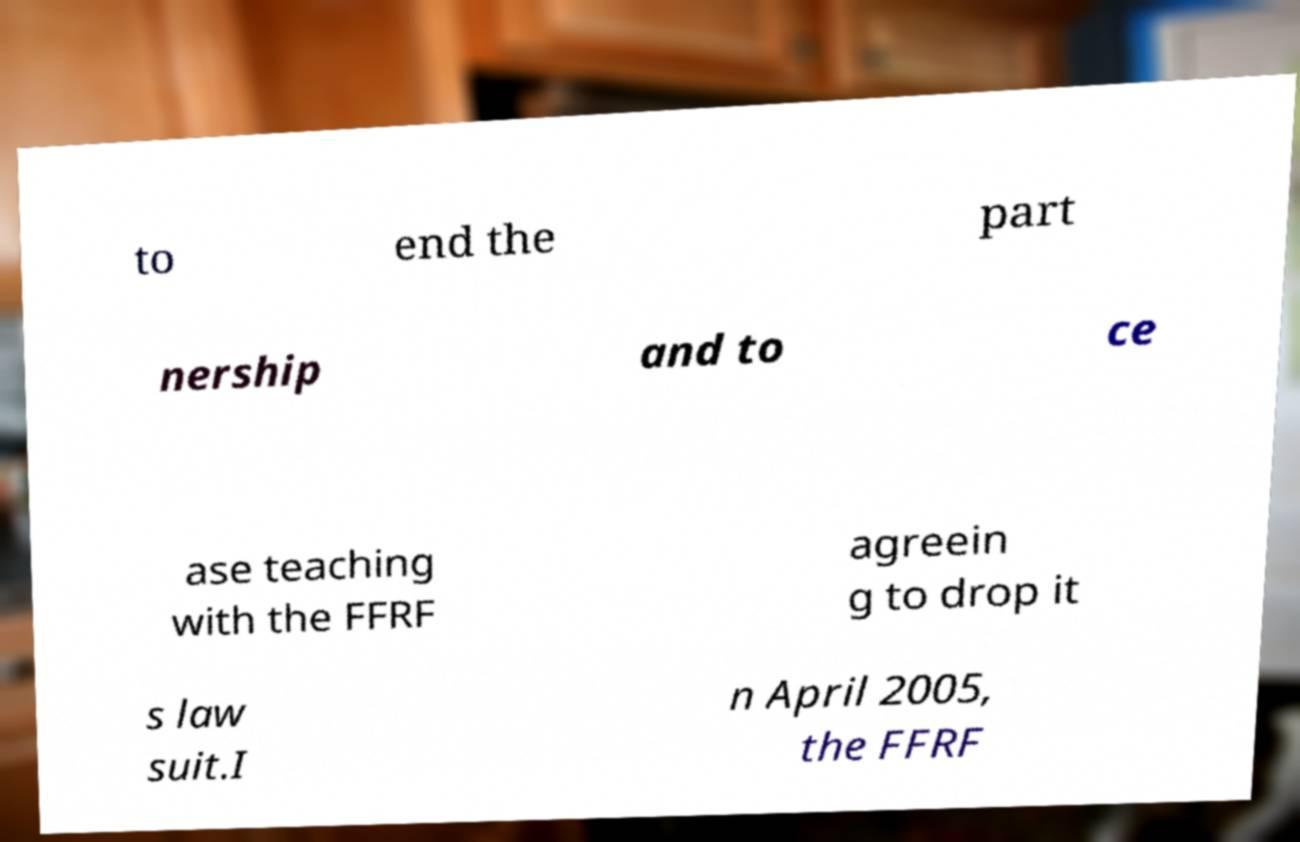Can you accurately transcribe the text from the provided image for me? to end the part nership and to ce ase teaching with the FFRF agreein g to drop it s law suit.I n April 2005, the FFRF 